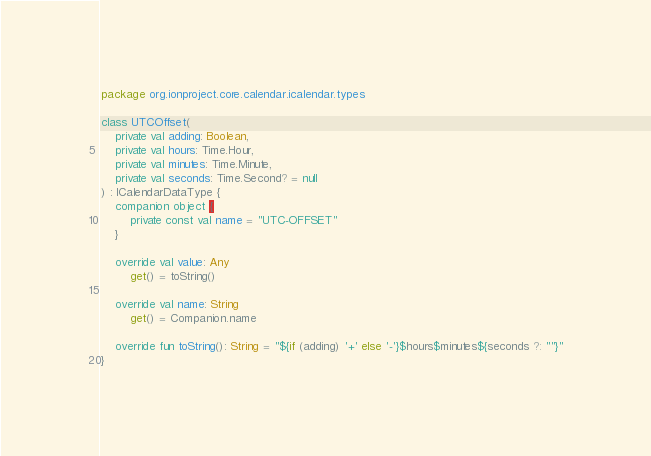<code> <loc_0><loc_0><loc_500><loc_500><_Kotlin_>package org.ionproject.core.calendar.icalendar.types

class UTCOffset(
    private val adding: Boolean,
    private val hours: Time.Hour,
    private val minutes: Time.Minute,
    private val seconds: Time.Second? = null
) : ICalendarDataType {
    companion object {
        private const val name = "UTC-OFFSET"
    }

    override val value: Any
        get() = toString()

    override val name: String
        get() = Companion.name

    override fun toString(): String = "${if (adding) '+' else '-'}$hours$minutes${seconds ?: ""}"
}
</code> 